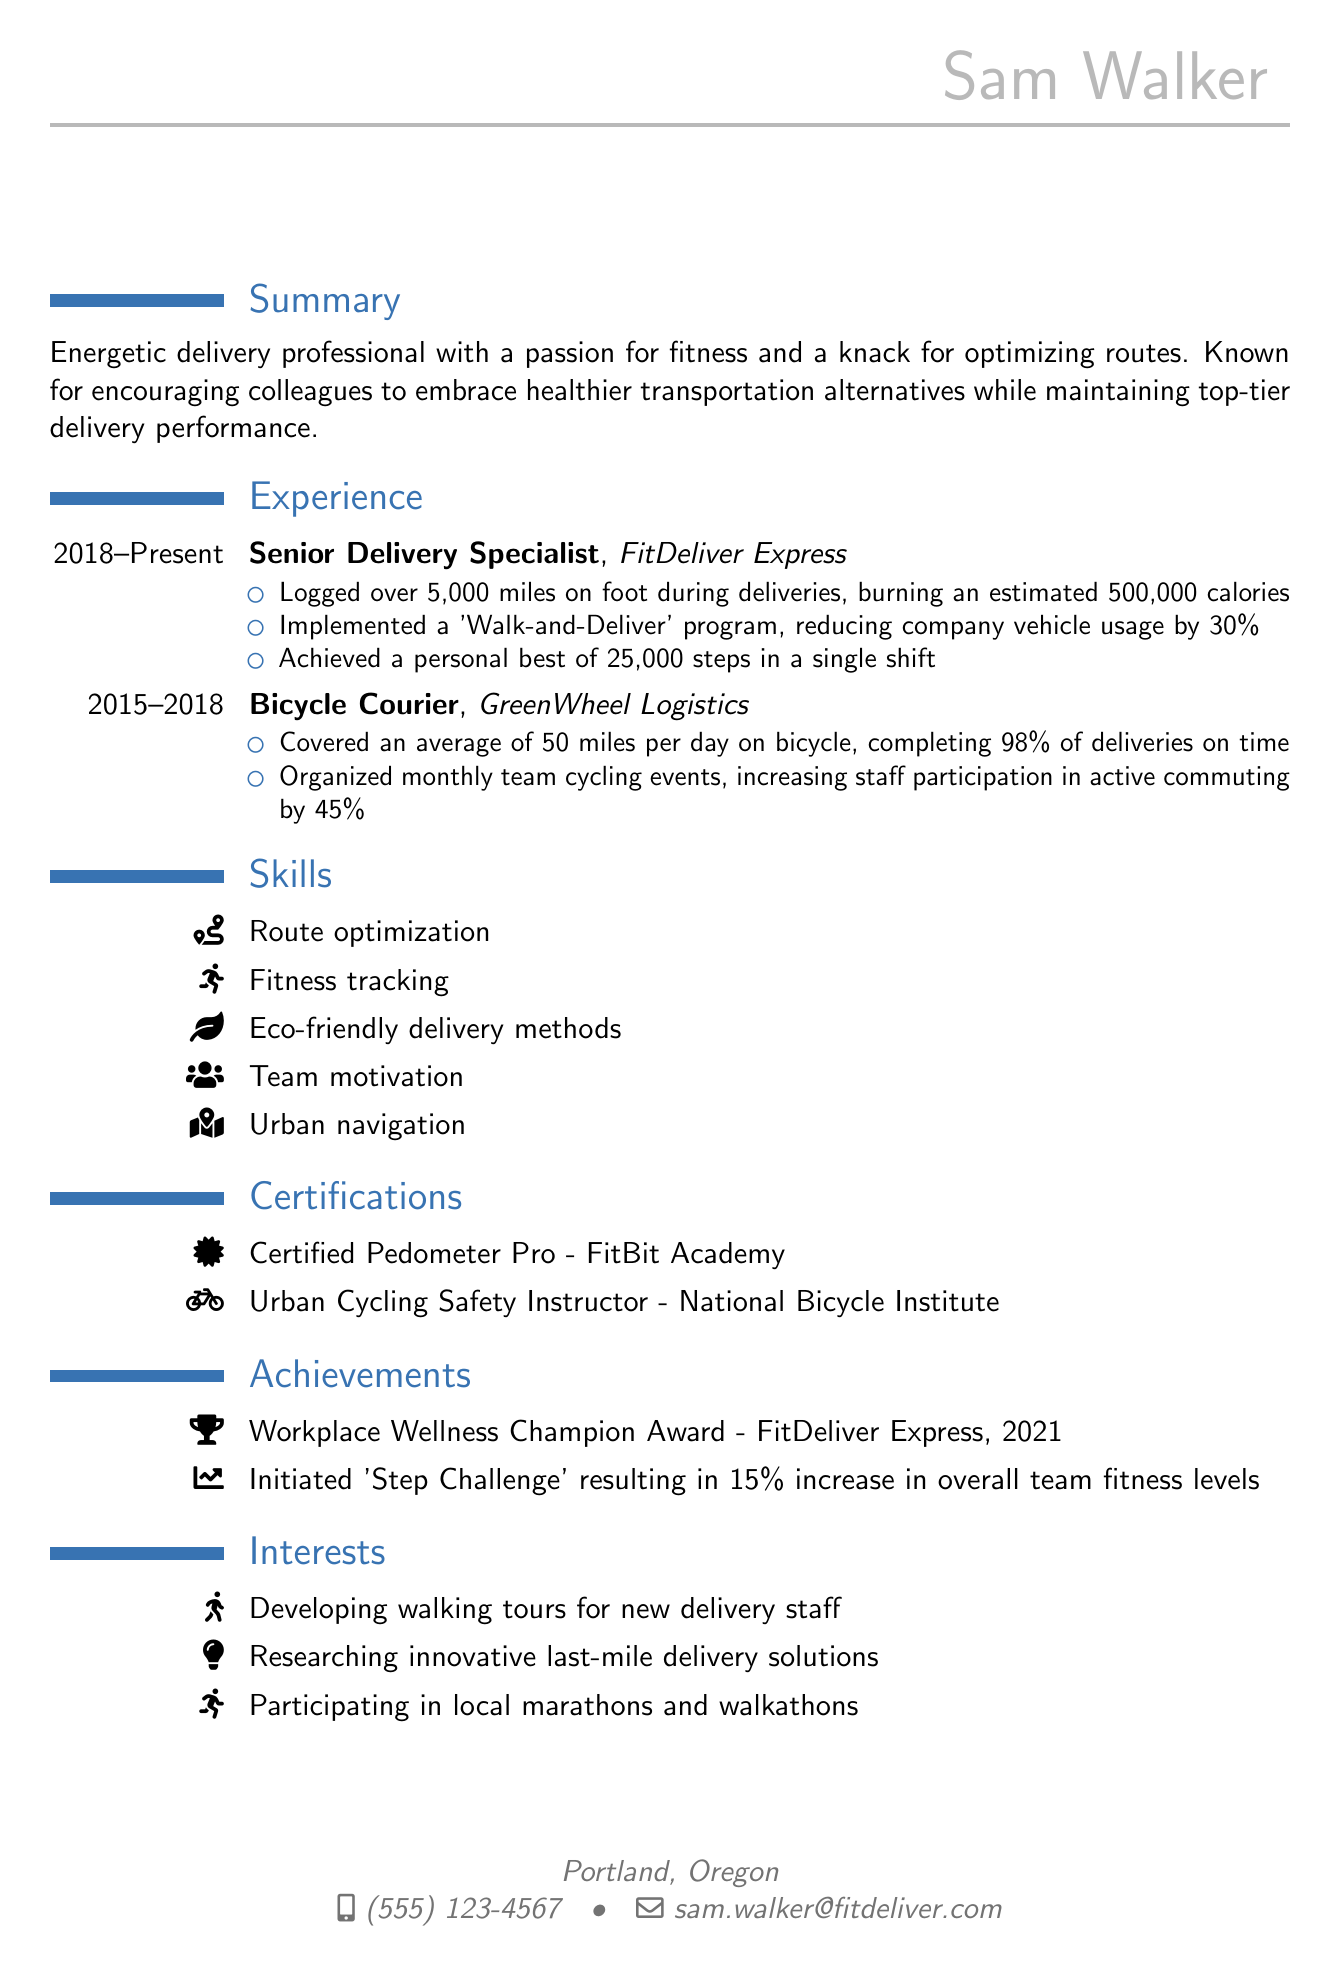What is the name of the delivery professional? The name is listed at the top of the resume under personal information.
Answer: Sam Walker What is Sam's email address? The email address is provided in the personal information section.
Answer: sam.walker@fitdeliver.com How many miles did Sam log on foot during deliveries? The number of miles logged is mentioned in the experience section under achievements.
Answer: over 5,000 miles What was the percentage reduction in vehicle usage due to the 'Walk-and-Deliver' program? This information can be found in the achievements of the Senior Delivery Specialist role.
Answer: 30% Which certification is Sam known for related to cycling? The certifications section lists Sam's qualifications, including one specifically for cycling.
Answer: Urban Cycling Safety Instructor What is the title of Sam's current position? The title is mentioned prominently in the experience section of the resume.
Answer: Senior Delivery Specialist What types of events did Sam organize to promote cycling? This detail can be found in the achievements of the Bicycle Courier role.
Answer: Monthly team cycling events What award did Sam receive in 2021? The awards section of the resume states specific recognitions received by Sam.
Answer: Workplace Wellness Champion Award What initiative led to a 15% increase in fitness levels? This information is specified in the achievements section of the resume.
Answer: 'Step Challenge' 